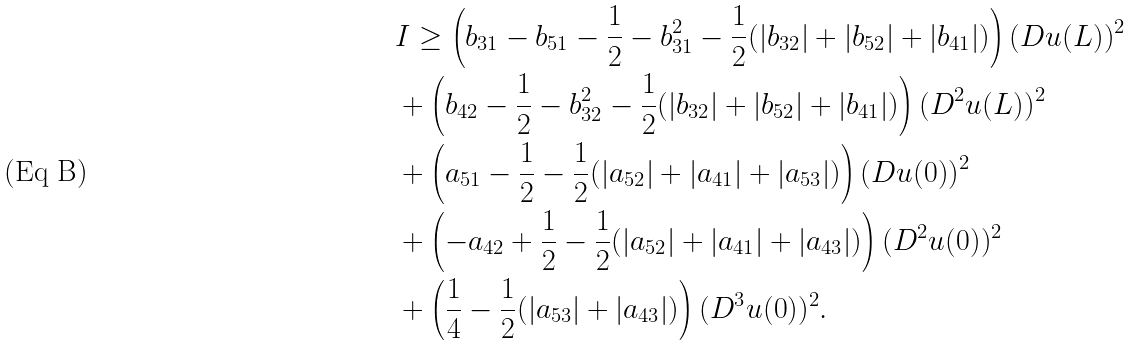<formula> <loc_0><loc_0><loc_500><loc_500>& I \geq \left ( b _ { 3 1 } - b _ { 5 1 } - \frac { 1 } { 2 } - b _ { 3 1 } ^ { 2 } - \frac { 1 } { 2 } ( | b _ { 3 2 } | + | b _ { 5 2 } | + | b _ { 4 1 } | ) \right ) ( D u ( L ) ) ^ { 2 } \\ & + \left ( b _ { 4 2 } - \frac { 1 } { 2 } - b _ { 3 2 } ^ { 2 } - \frac { 1 } { 2 } ( | b _ { 3 2 } | + | b _ { 5 2 } | + | b _ { 4 1 } | ) \right ) ( D ^ { 2 } u ( L ) ) ^ { 2 } \\ & + \left ( a _ { 5 1 } - \frac { 1 } { 2 } - \frac { 1 } { 2 } ( | a _ { 5 2 } | + | a _ { 4 1 } | + | a _ { 5 3 } | ) \right ) ( D u ( 0 ) ) ^ { 2 } \\ & + \left ( - a _ { 4 2 } + \frac { 1 } { 2 } - \frac { 1 } { 2 } ( | a _ { 5 2 } | + | a _ { 4 1 } | + | a _ { 4 3 } | ) \right ) ( D ^ { 2 } u ( 0 ) ) ^ { 2 } \\ & + \left ( \frac { 1 } { 4 } - \frac { 1 } { 2 } ( | a _ { 5 3 } | + | a _ { 4 3 } | ) \right ) ( D ^ { 3 } u ( 0 ) ) ^ { 2 } .</formula> 